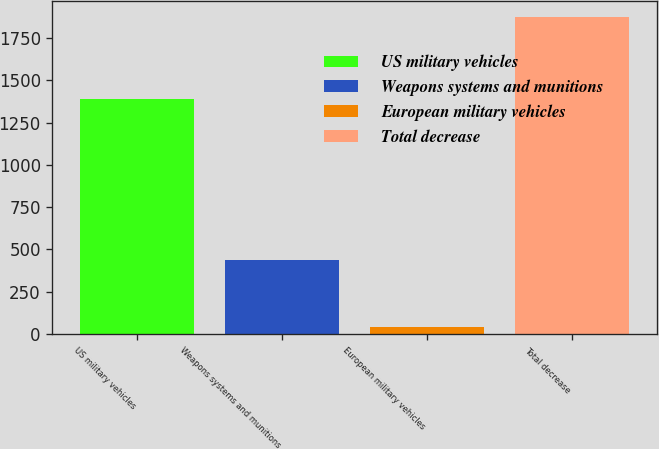Convert chart. <chart><loc_0><loc_0><loc_500><loc_500><bar_chart><fcel>US military vehicles<fcel>Weapons systems and munitions<fcel>European military vehicles<fcel>Total decrease<nl><fcel>1389<fcel>439<fcel>44<fcel>1872<nl></chart> 